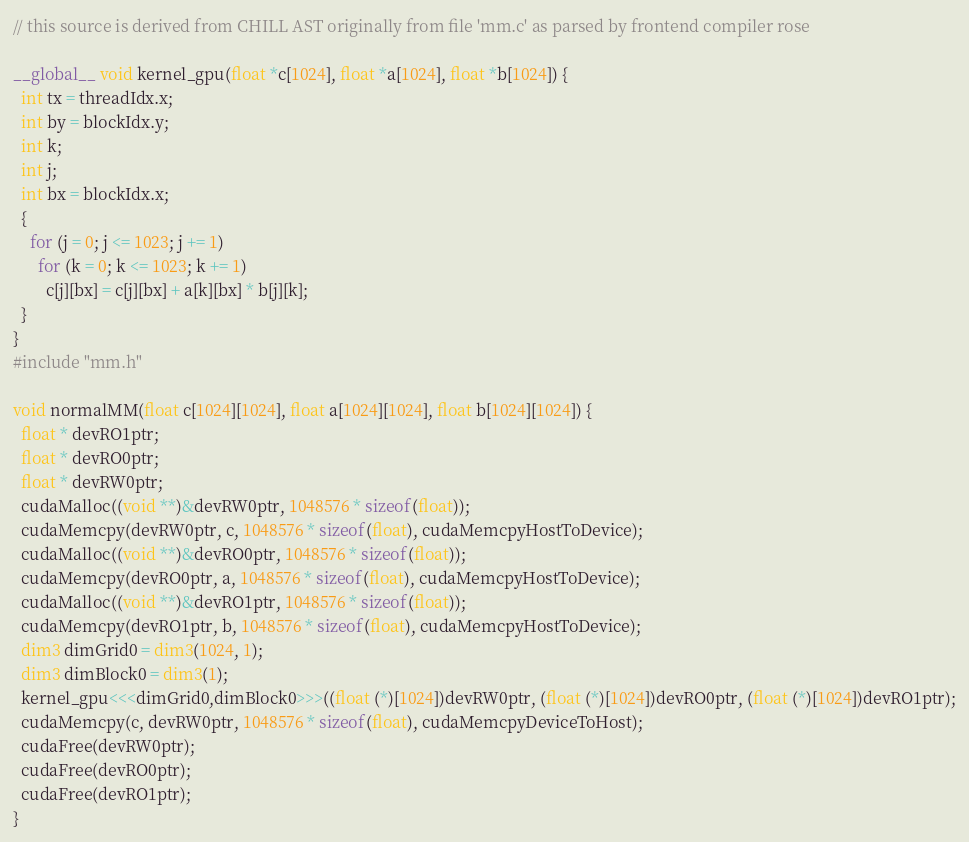<code> <loc_0><loc_0><loc_500><loc_500><_Cuda_>// this source is derived from CHILL AST originally from file 'mm.c' as parsed by frontend compiler rose

__global__ void kernel_gpu(float *c[1024], float *a[1024], float *b[1024]) {
  int tx = threadIdx.x;
  int by = blockIdx.y;
  int k;
  int j;
  int bx = blockIdx.x;
  {
    for (j = 0; j <= 1023; j += 1) 
      for (k = 0; k <= 1023; k += 1) 
        c[j][bx] = c[j][bx] + a[k][bx] * b[j][k];
  }
}
#include "mm.h"

void normalMM(float c[1024][1024], float a[1024][1024], float b[1024][1024]) {
  float * devRO1ptr;
  float * devRO0ptr;
  float * devRW0ptr;
  cudaMalloc((void **)&devRW0ptr, 1048576 * sizeof(float));
  cudaMemcpy(devRW0ptr, c, 1048576 * sizeof(float), cudaMemcpyHostToDevice);
  cudaMalloc((void **)&devRO0ptr, 1048576 * sizeof(float));
  cudaMemcpy(devRO0ptr, a, 1048576 * sizeof(float), cudaMemcpyHostToDevice);
  cudaMalloc((void **)&devRO1ptr, 1048576 * sizeof(float));
  cudaMemcpy(devRO1ptr, b, 1048576 * sizeof(float), cudaMemcpyHostToDevice);
  dim3 dimGrid0 = dim3(1024, 1);
  dim3 dimBlock0 = dim3(1);
  kernel_gpu<<<dimGrid0,dimBlock0>>>((float (*)[1024])devRW0ptr, (float (*)[1024])devRO0ptr, (float (*)[1024])devRO1ptr);
  cudaMemcpy(c, devRW0ptr, 1048576 * sizeof(float), cudaMemcpyDeviceToHost);
  cudaFree(devRW0ptr);
  cudaFree(devRO0ptr);
  cudaFree(devRO1ptr);
}
</code> 